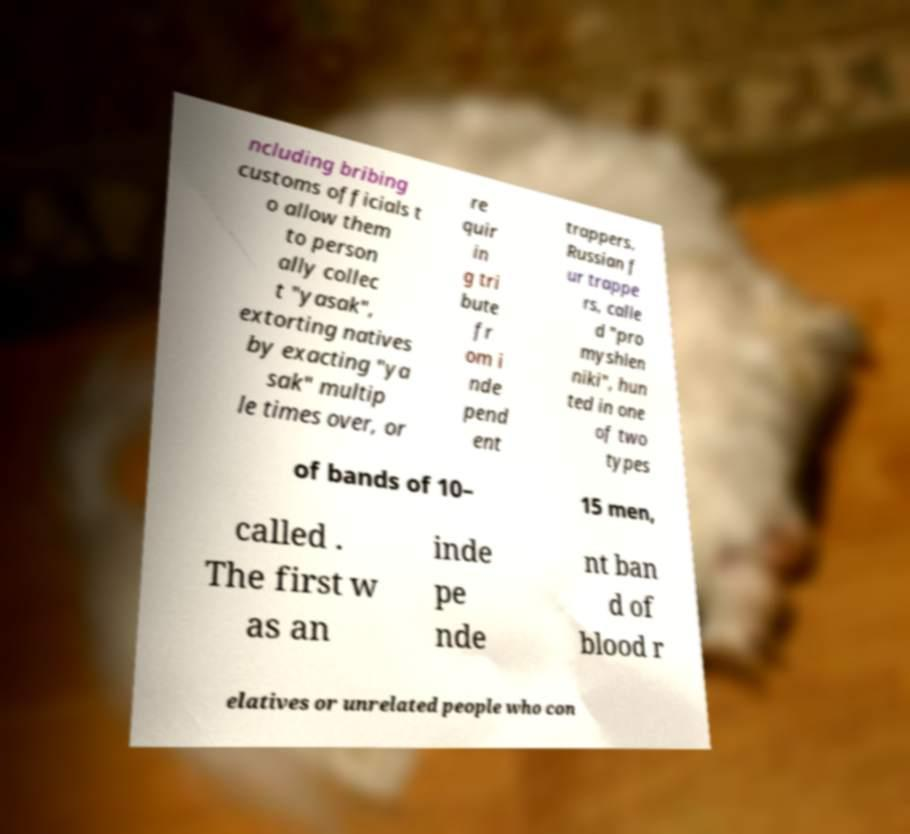For documentation purposes, I need the text within this image transcribed. Could you provide that? ncluding bribing customs officials t o allow them to person ally collec t "yasak", extorting natives by exacting "ya sak" multip le times over, or re quir in g tri bute fr om i nde pend ent trappers. Russian f ur trappe rs, calle d "pro myshlen niki", hun ted in one of two types of bands of 10– 15 men, called . The first w as an inde pe nde nt ban d of blood r elatives or unrelated people who con 